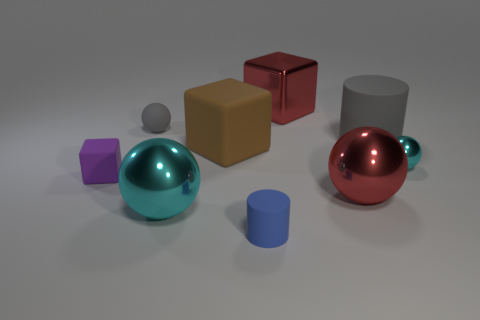Subtract 1 spheres. How many spheres are left? 3 Subtract all blue balls. Subtract all brown cylinders. How many balls are left? 4 Subtract all cylinders. How many objects are left? 7 Add 5 small purple rubber things. How many small purple rubber things are left? 6 Add 7 tiny cyan things. How many tiny cyan things exist? 8 Subtract 0 gray cubes. How many objects are left? 9 Subtract all big green metallic cylinders. Subtract all big cyan spheres. How many objects are left? 8 